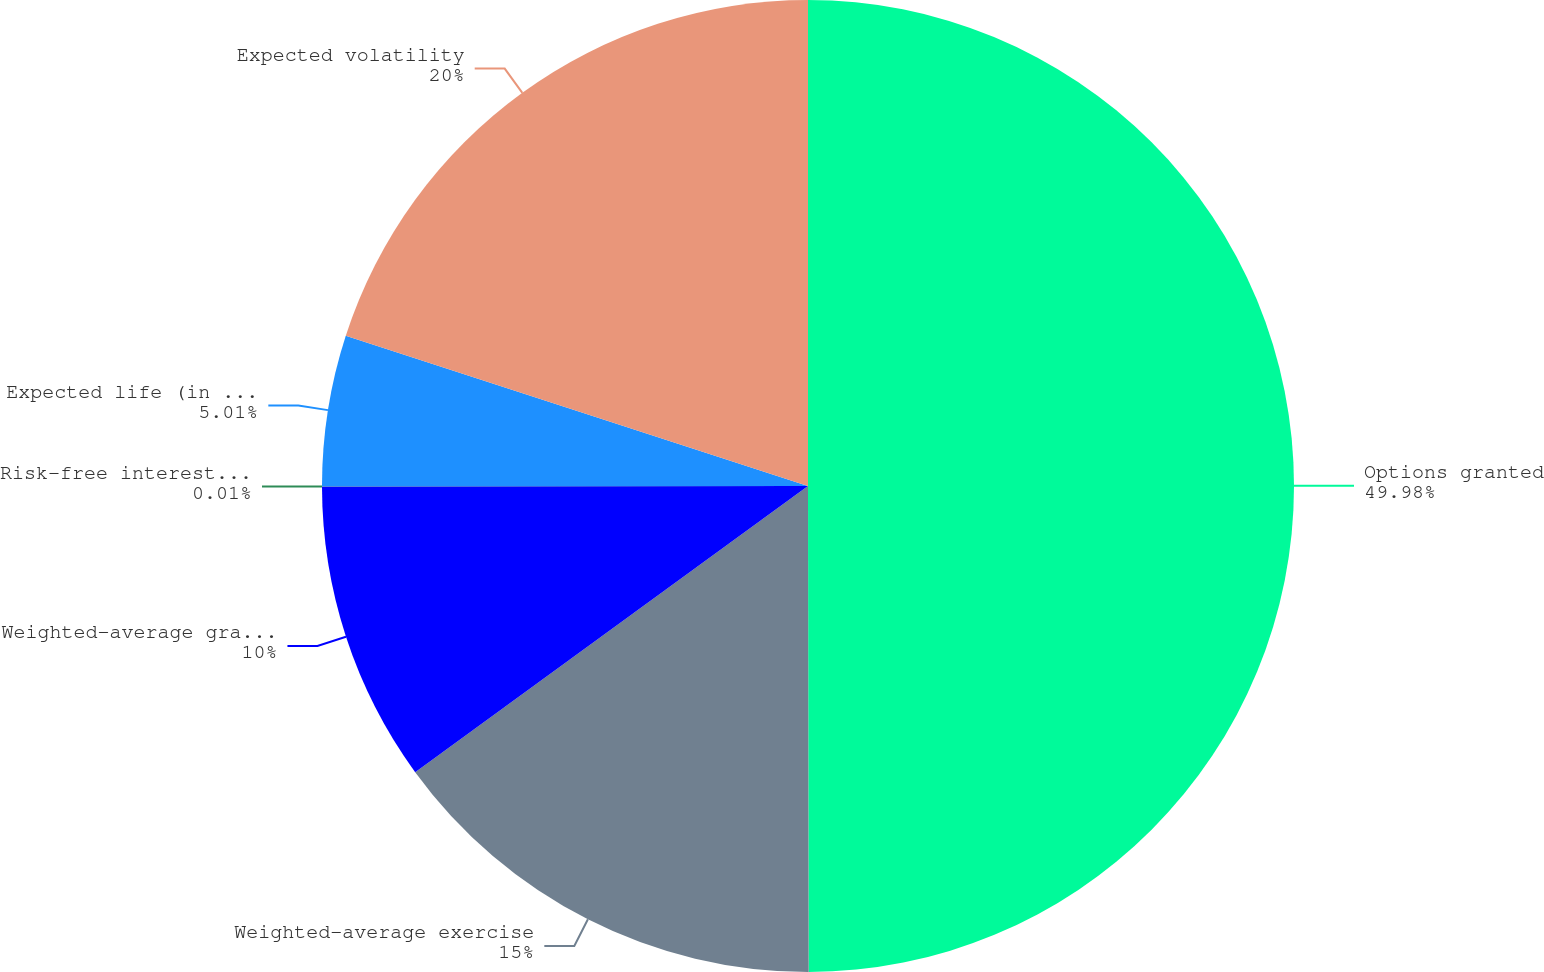<chart> <loc_0><loc_0><loc_500><loc_500><pie_chart><fcel>Options granted<fcel>Weighted-average exercise<fcel>Weighted-average grant date<fcel>Risk-free interest rates<fcel>Expected life (in years)<fcel>Expected volatility<nl><fcel>49.98%<fcel>15.0%<fcel>10.0%<fcel>0.01%<fcel>5.01%<fcel>20.0%<nl></chart> 